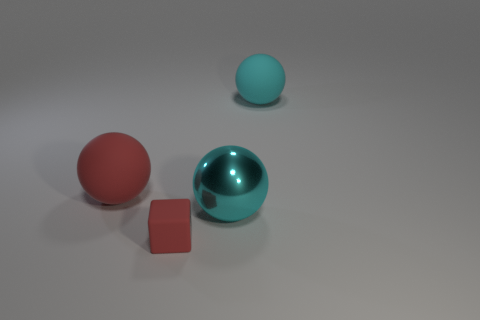There is another cyan sphere that is the same size as the metal ball; what is its material?
Ensure brevity in your answer.  Rubber. Is there a large gray object made of the same material as the small red block?
Make the answer very short. No. Do the large cyan rubber thing and the matte thing on the left side of the small red thing have the same shape?
Provide a short and direct response. Yes. What number of objects are in front of the cyan rubber ball and behind the small matte object?
Give a very brief answer. 2. Does the tiny cube have the same material as the cyan ball in front of the red rubber sphere?
Provide a short and direct response. No. Is the number of large red matte balls behind the tiny red matte object the same as the number of rubber spheres?
Offer a very short reply. No. What is the color of the large matte thing that is right of the big red object?
Keep it short and to the point. Cyan. Are there any other things that have the same size as the cyan rubber object?
Give a very brief answer. Yes. Do the cyan sphere that is in front of the cyan matte thing and the cyan rubber thing have the same size?
Provide a succinct answer. Yes. What material is the big object on the left side of the large cyan shiny thing?
Ensure brevity in your answer.  Rubber. 